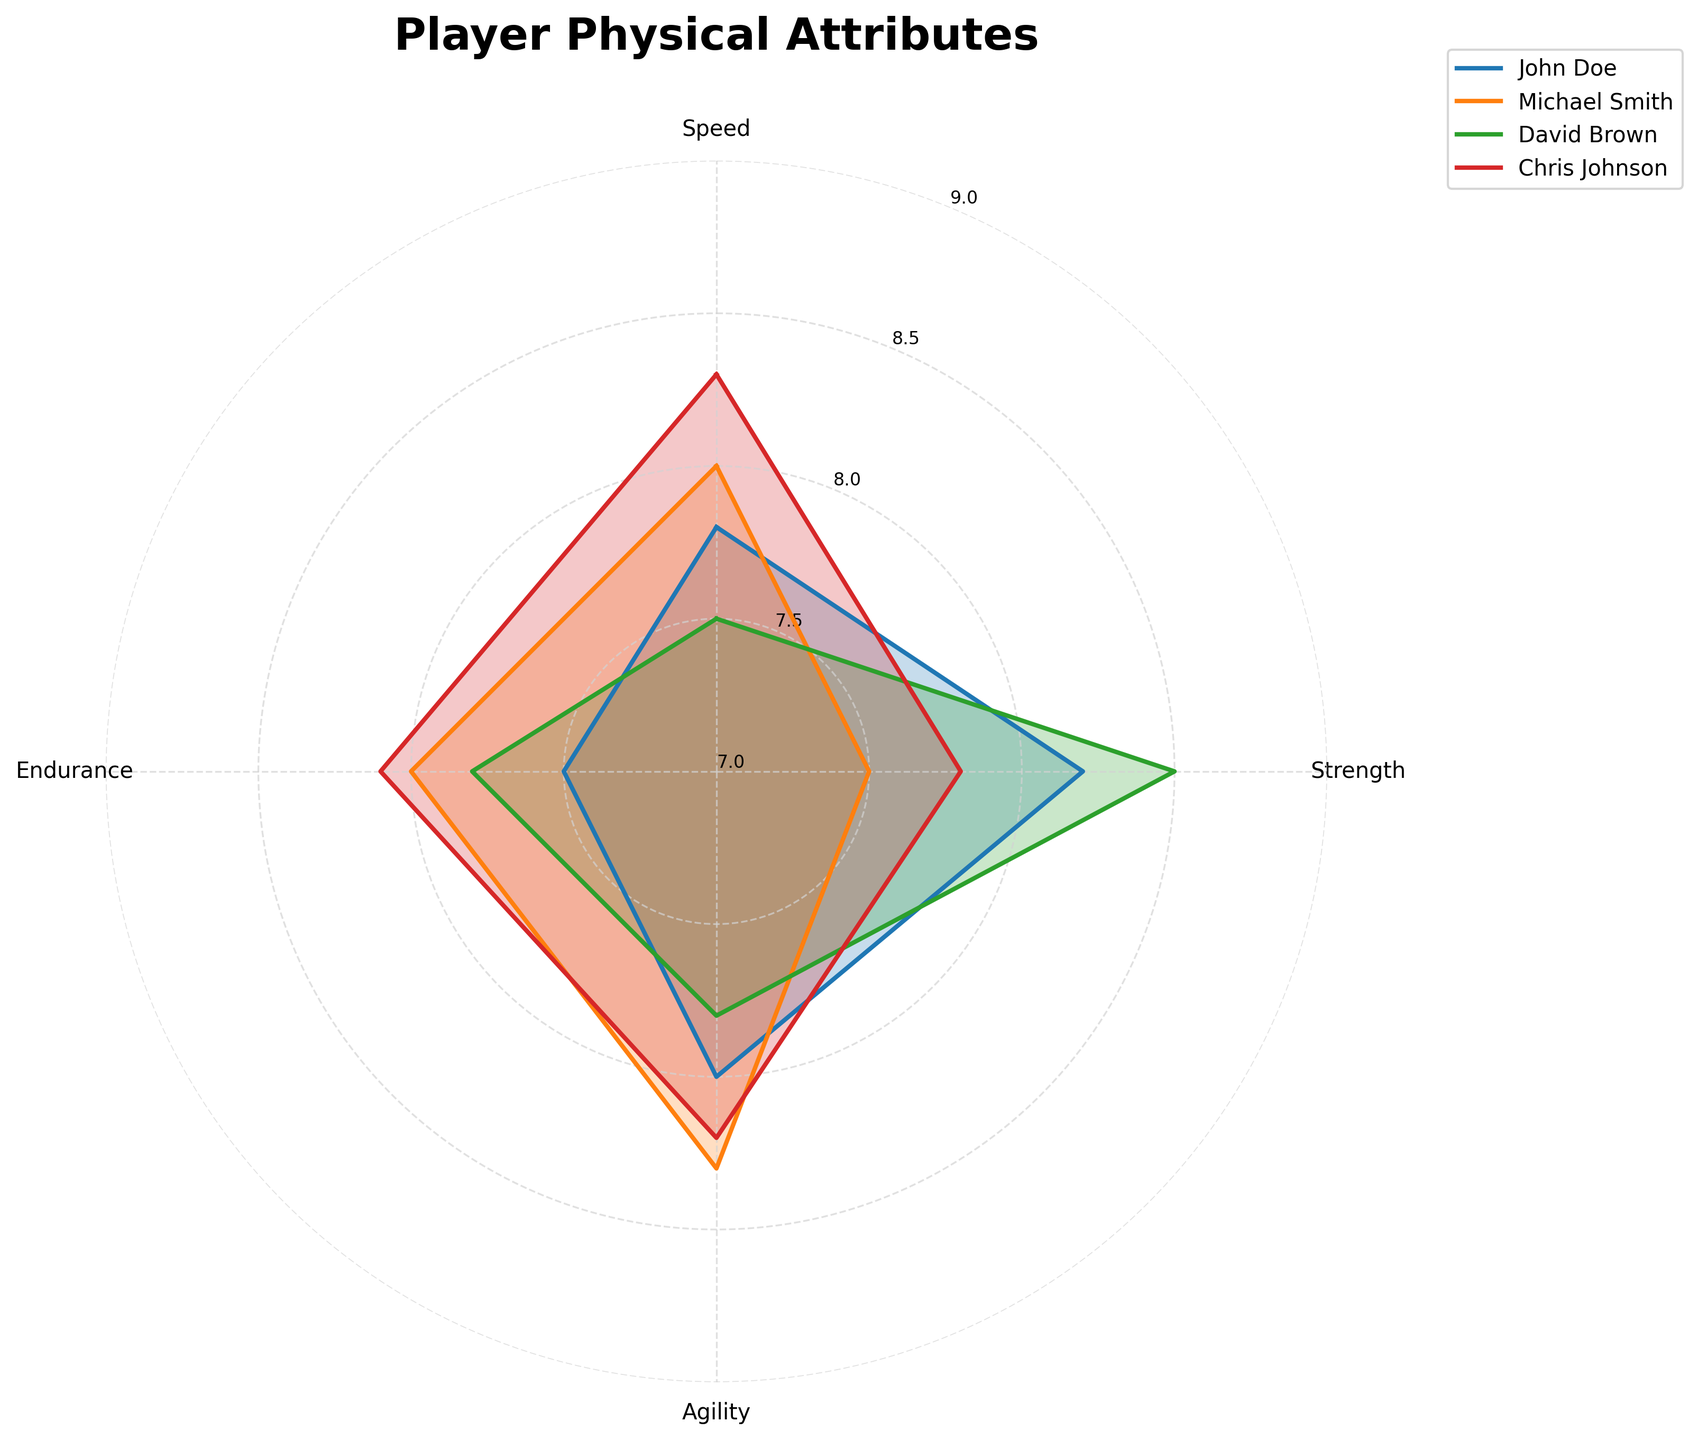What's the title of the figure? The title of the figure is located at the top and is usually the first piece of information provided. In this figure, it is clearly labeled above the radar chart.
Answer: Player Physical Attributes Which player has the highest speed? To find this, look at the 'Speed' attribute for all players. The 'Speed' values are marked on the radar chart for each player, and by comparing them, you can identify the highest one.
Answer: Chris Johnson Who has the lowest endurance? Examine the 'Endurance' values for all players on the radar chart. The player with the lowest value in the 'Endurance' category can be identified by comparing these values.
Answer: John Doe What is the average agility rating for all players? Calculate the average by adding the agility ratings of all players: 8.0 + 8.3 + 7.8 + 8.2, then divide by the number of players, which is 4. So, (8.0 + 8.3 + 7.8 + 8.2) / 4 = 8.075
Answer: 8.075 How does Michael Smith's strength compare to David Brown's strength? Compare the 'Strength' values for Michael Smith and David Brown on the radar chart. Michael Smith's strength is 7.5, while David Brown's strength is 8.5, so David Brown's strength is higher.
Answer: David Brown's strength is higher Which two players have the closest endurance ratings? Compare the 'Endurance' values for all players. John Doe has 7.5, Michael Smith has 8.0, David Brown has 7.8, and Chris Johnson has 8.1. The closest ratings are 8.0 (Michael Smith) and 8.1 (Chris Johnson), with a difference of 0.1.
Answer: Michael Smith and Chris Johnson Is there any player whose attributes are generally above 8 in all categories? Examine each player's ratings across all categories. No player has ratings above 8 in all categories, but Chris Johnson comes close with all attributes almost around 8.
Answer: No Which attribute does John Doe score the lowest in? Look at John Doe's scores in 'Speed', 'Strength', 'Agility', and 'Endurance'. The lowest score is 7.5 in 'Endurance'.
Answer: Endurance Which player's profile is most balanced across all attributes? A balanced profile will have the least variation between the highest and lowest scores. Chris Johnson has scores of 8.3, 7.8, 8.2, and 8.1, which shows a small range of variation.
Answer: Chris Johnson 